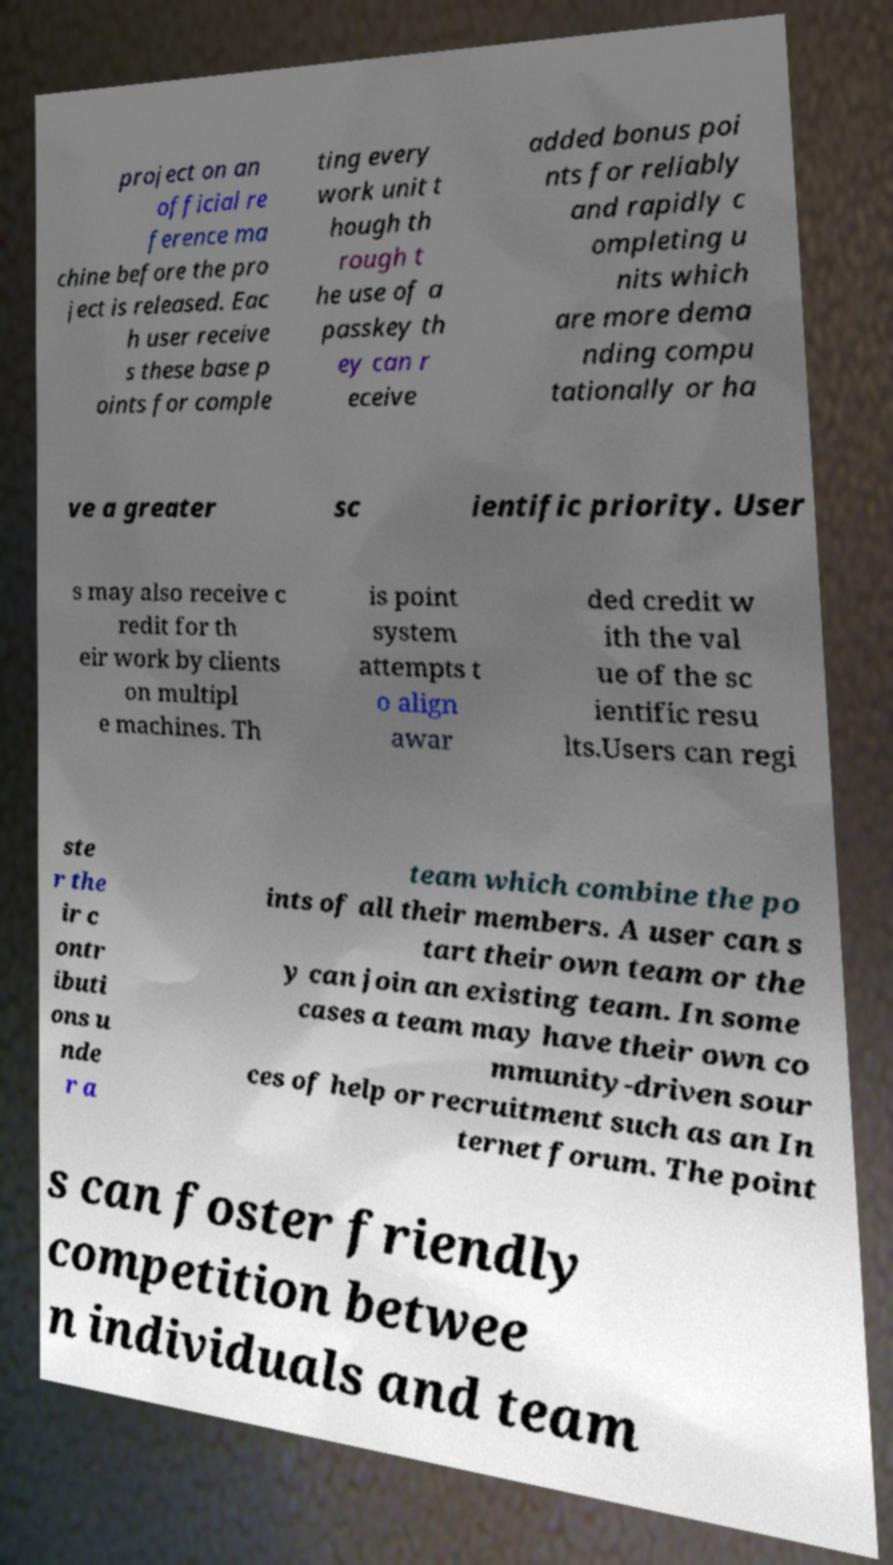Can you read and provide the text displayed in the image?This photo seems to have some interesting text. Can you extract and type it out for me? project on an official re ference ma chine before the pro ject is released. Eac h user receive s these base p oints for comple ting every work unit t hough th rough t he use of a passkey th ey can r eceive added bonus poi nts for reliably and rapidly c ompleting u nits which are more dema nding compu tationally or ha ve a greater sc ientific priority. User s may also receive c redit for th eir work by clients on multipl e machines. Th is point system attempts t o align awar ded credit w ith the val ue of the sc ientific resu lts.Users can regi ste r the ir c ontr ibuti ons u nde r a team which combine the po ints of all their members. A user can s tart their own team or the y can join an existing team. In some cases a team may have their own co mmunity-driven sour ces of help or recruitment such as an In ternet forum. The point s can foster friendly competition betwee n individuals and team 